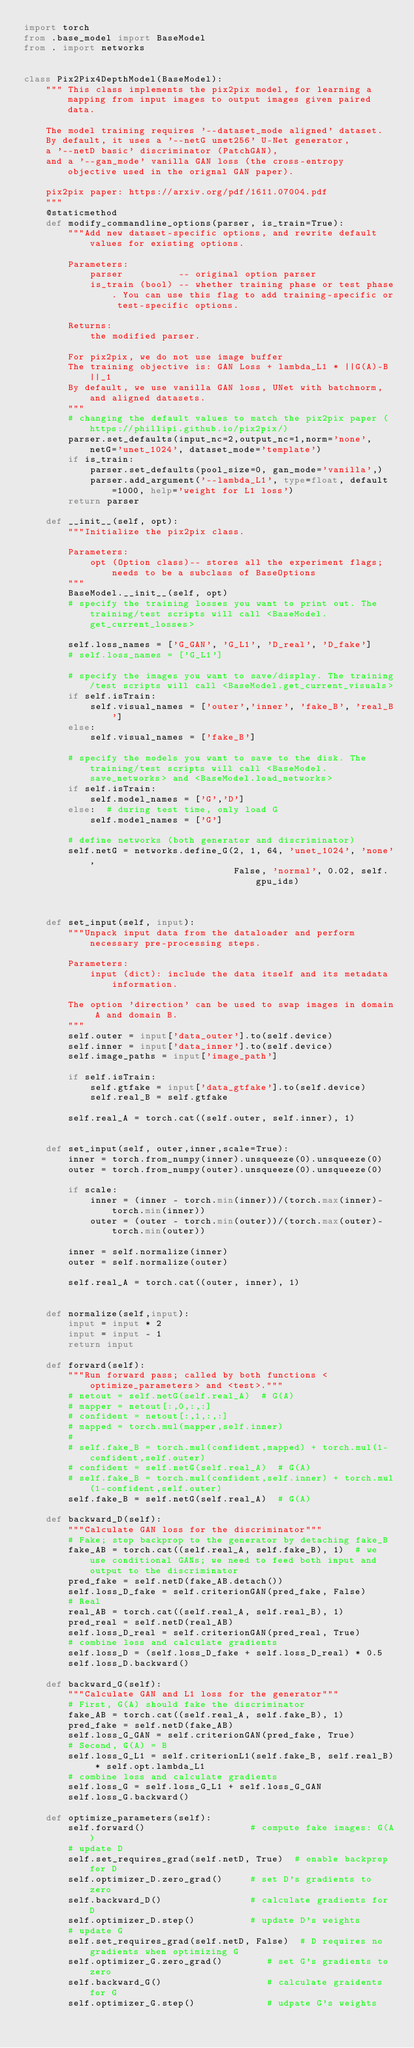<code> <loc_0><loc_0><loc_500><loc_500><_Python_>import torch
from .base_model import BaseModel
from . import networks


class Pix2Pix4DepthModel(BaseModel):
    """ This class implements the pix2pix model, for learning a mapping from input images to output images given paired data.

    The model training requires '--dataset_mode aligned' dataset.
    By default, it uses a '--netG unet256' U-Net generator,
    a '--netD basic' discriminator (PatchGAN),
    and a '--gan_mode' vanilla GAN loss (the cross-entropy objective used in the orignal GAN paper).

    pix2pix paper: https://arxiv.org/pdf/1611.07004.pdf
    """
    @staticmethod
    def modify_commandline_options(parser, is_train=True):
        """Add new dataset-specific options, and rewrite default values for existing options.

        Parameters:
            parser          -- original option parser
            is_train (bool) -- whether training phase or test phase. You can use this flag to add training-specific or test-specific options.

        Returns:
            the modified parser.

        For pix2pix, we do not use image buffer
        The training objective is: GAN Loss + lambda_L1 * ||G(A)-B||_1
        By default, we use vanilla GAN loss, UNet with batchnorm, and aligned datasets.
        """
        # changing the default values to match the pix2pix paper (https://phillipi.github.io/pix2pix/)
        parser.set_defaults(input_nc=2,output_nc=1,norm='none', netG='unet_1024', dataset_mode='template')
        if is_train:
            parser.set_defaults(pool_size=0, gan_mode='vanilla',)
            parser.add_argument('--lambda_L1', type=float, default=1000, help='weight for L1 loss')
        return parser

    def __init__(self, opt):
        """Initialize the pix2pix class.

        Parameters:
            opt (Option class)-- stores all the experiment flags; needs to be a subclass of BaseOptions
        """
        BaseModel.__init__(self, opt)
        # specify the training losses you want to print out. The training/test scripts will call <BaseModel.get_current_losses>

        self.loss_names = ['G_GAN', 'G_L1', 'D_real', 'D_fake']
        # self.loss_names = ['G_L1']

        # specify the images you want to save/display. The training/test scripts will call <BaseModel.get_current_visuals>
        if self.isTrain:
            self.visual_names = ['outer','inner', 'fake_B', 'real_B']
        else:
            self.visual_names = ['fake_B']

        # specify the models you want to save to the disk. The training/test scripts will call <BaseModel.save_networks> and <BaseModel.load_networks>
        if self.isTrain:
            self.model_names = ['G','D']
        else:  # during test time, only load G
            self.model_names = ['G']

        # define networks (both generator and discriminator)
        self.netG = networks.define_G(2, 1, 64, 'unet_1024', 'none',
                                      False, 'normal', 0.02, self.gpu_ids)



    def set_input(self, input):
        """Unpack input data from the dataloader and perform necessary pre-processing steps.

        Parameters:
            input (dict): include the data itself and its metadata information.

        The option 'direction' can be used to swap images in domain A and domain B.
        """
        self.outer = input['data_outer'].to(self.device)
        self.inner = input['data_inner'].to(self.device)
        self.image_paths = input['image_path']

        if self.isTrain:
            self.gtfake = input['data_gtfake'].to(self.device)
            self.real_B = self.gtfake

        self.real_A = torch.cat((self.outer, self.inner), 1)


    def set_input(self, outer,inner,scale=True):
        inner = torch.from_numpy(inner).unsqueeze(0).unsqueeze(0)
        outer = torch.from_numpy(outer).unsqueeze(0).unsqueeze(0)

        if scale:
            inner = (inner - torch.min(inner))/(torch.max(inner)-torch.min(inner))
            outer = (outer - torch.min(outer))/(torch.max(outer)-torch.min(outer))

        inner = self.normalize(inner)
        outer = self.normalize(outer)

        self.real_A = torch.cat((outer, inner), 1)


    def normalize(self,input):
        input = input * 2
        input = input - 1
        return input

    def forward(self):
        """Run forward pass; called by both functions <optimize_parameters> and <test>."""
        # netout = self.netG(self.real_A)  # G(A)
        # mapper = netout[:,0,:,:]
        # confident = netout[:,1,:,:]
        # mapped = torch.mul(mapper,self.inner)
        #
        # self.fake_B = torch.mul(confident,mapped) + torch.mul(1-confident,self.outer)
        # confident = self.netG(self.real_A)  # G(A)
        # self.fake_B = torch.mul(confident,self.inner) + torch.mul(1-confident,self.outer)
        self.fake_B = self.netG(self.real_A)  # G(A)

    def backward_D(self):
        """Calculate GAN loss for the discriminator"""
        # Fake; stop backprop to the generator by detaching fake_B
        fake_AB = torch.cat((self.real_A, self.fake_B), 1)  # we use conditional GANs; we need to feed both input and output to the discriminator
        pred_fake = self.netD(fake_AB.detach())
        self.loss_D_fake = self.criterionGAN(pred_fake, False)
        # Real
        real_AB = torch.cat((self.real_A, self.real_B), 1)
        pred_real = self.netD(real_AB)
        self.loss_D_real = self.criterionGAN(pred_real, True)
        # combine loss and calculate gradients
        self.loss_D = (self.loss_D_fake + self.loss_D_real) * 0.5
        self.loss_D.backward()

    def backward_G(self):
        """Calculate GAN and L1 loss for the generator"""
        # First, G(A) should fake the discriminator
        fake_AB = torch.cat((self.real_A, self.fake_B), 1)
        pred_fake = self.netD(fake_AB)
        self.loss_G_GAN = self.criterionGAN(pred_fake, True)
        # Second, G(A) = B
        self.loss_G_L1 = self.criterionL1(self.fake_B, self.real_B) * self.opt.lambda_L1
        # combine loss and calculate gradients
        self.loss_G = self.loss_G_L1 + self.loss_G_GAN
        self.loss_G.backward()

    def optimize_parameters(self):
        self.forward()                   # compute fake images: G(A)
        # update D
        self.set_requires_grad(self.netD, True)  # enable backprop for D
        self.optimizer_D.zero_grad()     # set D's gradients to zero
        self.backward_D()                # calculate gradients for D
        self.optimizer_D.step()          # update D's weights
        # update G
        self.set_requires_grad(self.netD, False)  # D requires no gradients when optimizing G
        self.optimizer_G.zero_grad()        # set G's gradients to zero
        self.backward_G()                   # calculate graidents for G
        self.optimizer_G.step()             # udpate G's weights</code> 